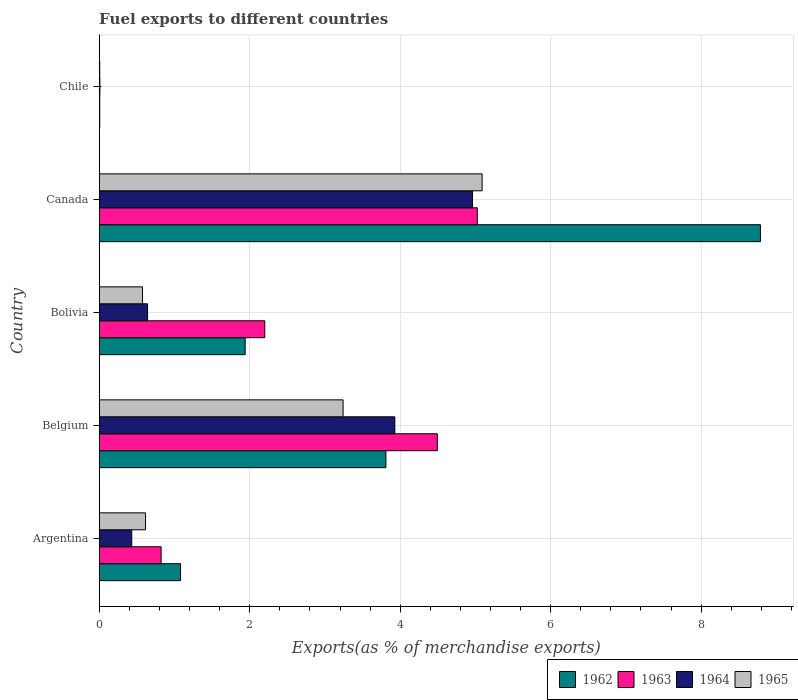Are the number of bars per tick equal to the number of legend labels?
Offer a very short reply. Yes. Are the number of bars on each tick of the Y-axis equal?
Provide a short and direct response. Yes. How many bars are there on the 2nd tick from the bottom?
Offer a very short reply. 4. What is the label of the 5th group of bars from the top?
Your answer should be compact. Argentina. What is the percentage of exports to different countries in 1962 in Belgium?
Offer a very short reply. 3.81. Across all countries, what is the maximum percentage of exports to different countries in 1963?
Ensure brevity in your answer.  5.02. Across all countries, what is the minimum percentage of exports to different countries in 1964?
Your answer should be compact. 0.01. In which country was the percentage of exports to different countries in 1965 minimum?
Give a very brief answer. Chile. What is the total percentage of exports to different countries in 1963 in the graph?
Your response must be concise. 12.55. What is the difference between the percentage of exports to different countries in 1962 in Belgium and that in Bolivia?
Keep it short and to the point. 1.87. What is the difference between the percentage of exports to different countries in 1964 in Chile and the percentage of exports to different countries in 1963 in Belgium?
Make the answer very short. -4.48. What is the average percentage of exports to different countries in 1965 per country?
Keep it short and to the point. 1.91. What is the difference between the percentage of exports to different countries in 1962 and percentage of exports to different countries in 1965 in Canada?
Your response must be concise. 3.7. What is the ratio of the percentage of exports to different countries in 1965 in Argentina to that in Canada?
Your response must be concise. 0.12. What is the difference between the highest and the second highest percentage of exports to different countries in 1965?
Ensure brevity in your answer.  1.85. What is the difference between the highest and the lowest percentage of exports to different countries in 1962?
Your answer should be very brief. 8.78. Is it the case that in every country, the sum of the percentage of exports to different countries in 1965 and percentage of exports to different countries in 1963 is greater than the sum of percentage of exports to different countries in 1964 and percentage of exports to different countries in 1962?
Your answer should be very brief. No. What does the 4th bar from the bottom in Belgium represents?
Keep it short and to the point. 1965. Is it the case that in every country, the sum of the percentage of exports to different countries in 1962 and percentage of exports to different countries in 1964 is greater than the percentage of exports to different countries in 1965?
Offer a terse response. Yes. How many bars are there?
Give a very brief answer. 20. How many countries are there in the graph?
Give a very brief answer. 5. What is the difference between two consecutive major ticks on the X-axis?
Offer a very short reply. 2. Does the graph contain any zero values?
Your response must be concise. No. Where does the legend appear in the graph?
Your answer should be compact. Bottom right. How many legend labels are there?
Provide a succinct answer. 4. How are the legend labels stacked?
Make the answer very short. Horizontal. What is the title of the graph?
Your response must be concise. Fuel exports to different countries. Does "2005" appear as one of the legend labels in the graph?
Your answer should be very brief. No. What is the label or title of the X-axis?
Your response must be concise. Exports(as % of merchandise exports). What is the Exports(as % of merchandise exports) of 1962 in Argentina?
Provide a short and direct response. 1.08. What is the Exports(as % of merchandise exports) in 1963 in Argentina?
Give a very brief answer. 0.82. What is the Exports(as % of merchandise exports) in 1964 in Argentina?
Make the answer very short. 0.43. What is the Exports(as % of merchandise exports) in 1965 in Argentina?
Give a very brief answer. 0.62. What is the Exports(as % of merchandise exports) of 1962 in Belgium?
Provide a short and direct response. 3.81. What is the Exports(as % of merchandise exports) in 1963 in Belgium?
Give a very brief answer. 4.49. What is the Exports(as % of merchandise exports) in 1964 in Belgium?
Your response must be concise. 3.93. What is the Exports(as % of merchandise exports) in 1965 in Belgium?
Ensure brevity in your answer.  3.24. What is the Exports(as % of merchandise exports) of 1962 in Bolivia?
Offer a terse response. 1.94. What is the Exports(as % of merchandise exports) of 1963 in Bolivia?
Make the answer very short. 2.2. What is the Exports(as % of merchandise exports) of 1964 in Bolivia?
Keep it short and to the point. 0.64. What is the Exports(as % of merchandise exports) of 1965 in Bolivia?
Offer a very short reply. 0.58. What is the Exports(as % of merchandise exports) of 1962 in Canada?
Your answer should be compact. 8.79. What is the Exports(as % of merchandise exports) in 1963 in Canada?
Your answer should be very brief. 5.02. What is the Exports(as % of merchandise exports) in 1964 in Canada?
Keep it short and to the point. 4.96. What is the Exports(as % of merchandise exports) in 1965 in Canada?
Provide a short and direct response. 5.09. What is the Exports(as % of merchandise exports) in 1962 in Chile?
Make the answer very short. 0.01. What is the Exports(as % of merchandise exports) in 1963 in Chile?
Offer a terse response. 0.01. What is the Exports(as % of merchandise exports) in 1964 in Chile?
Ensure brevity in your answer.  0.01. What is the Exports(as % of merchandise exports) in 1965 in Chile?
Give a very brief answer. 0.01. Across all countries, what is the maximum Exports(as % of merchandise exports) of 1962?
Ensure brevity in your answer.  8.79. Across all countries, what is the maximum Exports(as % of merchandise exports) of 1963?
Keep it short and to the point. 5.02. Across all countries, what is the maximum Exports(as % of merchandise exports) of 1964?
Your answer should be compact. 4.96. Across all countries, what is the maximum Exports(as % of merchandise exports) in 1965?
Provide a succinct answer. 5.09. Across all countries, what is the minimum Exports(as % of merchandise exports) of 1962?
Your response must be concise. 0.01. Across all countries, what is the minimum Exports(as % of merchandise exports) of 1963?
Make the answer very short. 0.01. Across all countries, what is the minimum Exports(as % of merchandise exports) of 1964?
Provide a short and direct response. 0.01. Across all countries, what is the minimum Exports(as % of merchandise exports) in 1965?
Make the answer very short. 0.01. What is the total Exports(as % of merchandise exports) of 1962 in the graph?
Your answer should be compact. 15.63. What is the total Exports(as % of merchandise exports) of 1963 in the graph?
Provide a succinct answer. 12.55. What is the total Exports(as % of merchandise exports) of 1964 in the graph?
Your answer should be very brief. 9.97. What is the total Exports(as % of merchandise exports) in 1965 in the graph?
Offer a very short reply. 9.53. What is the difference between the Exports(as % of merchandise exports) of 1962 in Argentina and that in Belgium?
Keep it short and to the point. -2.73. What is the difference between the Exports(as % of merchandise exports) in 1963 in Argentina and that in Belgium?
Ensure brevity in your answer.  -3.67. What is the difference between the Exports(as % of merchandise exports) in 1964 in Argentina and that in Belgium?
Make the answer very short. -3.5. What is the difference between the Exports(as % of merchandise exports) in 1965 in Argentina and that in Belgium?
Keep it short and to the point. -2.63. What is the difference between the Exports(as % of merchandise exports) of 1962 in Argentina and that in Bolivia?
Keep it short and to the point. -0.86. What is the difference between the Exports(as % of merchandise exports) of 1963 in Argentina and that in Bolivia?
Keep it short and to the point. -1.38. What is the difference between the Exports(as % of merchandise exports) in 1964 in Argentina and that in Bolivia?
Offer a very short reply. -0.21. What is the difference between the Exports(as % of merchandise exports) in 1965 in Argentina and that in Bolivia?
Your answer should be compact. 0.04. What is the difference between the Exports(as % of merchandise exports) of 1962 in Argentina and that in Canada?
Offer a terse response. -7.71. What is the difference between the Exports(as % of merchandise exports) of 1963 in Argentina and that in Canada?
Provide a short and direct response. -4.2. What is the difference between the Exports(as % of merchandise exports) of 1964 in Argentina and that in Canada?
Provide a succinct answer. -4.53. What is the difference between the Exports(as % of merchandise exports) in 1965 in Argentina and that in Canada?
Your answer should be compact. -4.47. What is the difference between the Exports(as % of merchandise exports) in 1962 in Argentina and that in Chile?
Keep it short and to the point. 1.07. What is the difference between the Exports(as % of merchandise exports) of 1963 in Argentina and that in Chile?
Ensure brevity in your answer.  0.82. What is the difference between the Exports(as % of merchandise exports) in 1964 in Argentina and that in Chile?
Provide a succinct answer. 0.42. What is the difference between the Exports(as % of merchandise exports) in 1965 in Argentina and that in Chile?
Ensure brevity in your answer.  0.61. What is the difference between the Exports(as % of merchandise exports) in 1962 in Belgium and that in Bolivia?
Offer a terse response. 1.87. What is the difference between the Exports(as % of merchandise exports) in 1963 in Belgium and that in Bolivia?
Your answer should be very brief. 2.29. What is the difference between the Exports(as % of merchandise exports) in 1964 in Belgium and that in Bolivia?
Keep it short and to the point. 3.29. What is the difference between the Exports(as % of merchandise exports) in 1965 in Belgium and that in Bolivia?
Keep it short and to the point. 2.67. What is the difference between the Exports(as % of merchandise exports) in 1962 in Belgium and that in Canada?
Your answer should be very brief. -4.98. What is the difference between the Exports(as % of merchandise exports) of 1963 in Belgium and that in Canada?
Offer a very short reply. -0.53. What is the difference between the Exports(as % of merchandise exports) of 1964 in Belgium and that in Canada?
Your response must be concise. -1.03. What is the difference between the Exports(as % of merchandise exports) in 1965 in Belgium and that in Canada?
Your answer should be very brief. -1.85. What is the difference between the Exports(as % of merchandise exports) in 1962 in Belgium and that in Chile?
Offer a very short reply. 3.8. What is the difference between the Exports(as % of merchandise exports) in 1963 in Belgium and that in Chile?
Keep it short and to the point. 4.49. What is the difference between the Exports(as % of merchandise exports) of 1964 in Belgium and that in Chile?
Give a very brief answer. 3.92. What is the difference between the Exports(as % of merchandise exports) in 1965 in Belgium and that in Chile?
Offer a terse response. 3.23. What is the difference between the Exports(as % of merchandise exports) of 1962 in Bolivia and that in Canada?
Your answer should be very brief. -6.85. What is the difference between the Exports(as % of merchandise exports) of 1963 in Bolivia and that in Canada?
Provide a short and direct response. -2.82. What is the difference between the Exports(as % of merchandise exports) in 1964 in Bolivia and that in Canada?
Make the answer very short. -4.32. What is the difference between the Exports(as % of merchandise exports) in 1965 in Bolivia and that in Canada?
Offer a terse response. -4.51. What is the difference between the Exports(as % of merchandise exports) in 1962 in Bolivia and that in Chile?
Give a very brief answer. 1.93. What is the difference between the Exports(as % of merchandise exports) of 1963 in Bolivia and that in Chile?
Offer a very short reply. 2.19. What is the difference between the Exports(as % of merchandise exports) of 1964 in Bolivia and that in Chile?
Your response must be concise. 0.63. What is the difference between the Exports(as % of merchandise exports) of 1965 in Bolivia and that in Chile?
Ensure brevity in your answer.  0.57. What is the difference between the Exports(as % of merchandise exports) in 1962 in Canada and that in Chile?
Your answer should be compact. 8.78. What is the difference between the Exports(as % of merchandise exports) of 1963 in Canada and that in Chile?
Keep it short and to the point. 5.02. What is the difference between the Exports(as % of merchandise exports) of 1964 in Canada and that in Chile?
Provide a short and direct response. 4.95. What is the difference between the Exports(as % of merchandise exports) in 1965 in Canada and that in Chile?
Ensure brevity in your answer.  5.08. What is the difference between the Exports(as % of merchandise exports) of 1962 in Argentina and the Exports(as % of merchandise exports) of 1963 in Belgium?
Offer a terse response. -3.41. What is the difference between the Exports(as % of merchandise exports) of 1962 in Argentina and the Exports(as % of merchandise exports) of 1964 in Belgium?
Keep it short and to the point. -2.85. What is the difference between the Exports(as % of merchandise exports) of 1962 in Argentina and the Exports(as % of merchandise exports) of 1965 in Belgium?
Provide a short and direct response. -2.16. What is the difference between the Exports(as % of merchandise exports) in 1963 in Argentina and the Exports(as % of merchandise exports) in 1964 in Belgium?
Offer a very short reply. -3.11. What is the difference between the Exports(as % of merchandise exports) of 1963 in Argentina and the Exports(as % of merchandise exports) of 1965 in Belgium?
Provide a succinct answer. -2.42. What is the difference between the Exports(as % of merchandise exports) in 1964 in Argentina and the Exports(as % of merchandise exports) in 1965 in Belgium?
Make the answer very short. -2.81. What is the difference between the Exports(as % of merchandise exports) in 1962 in Argentina and the Exports(as % of merchandise exports) in 1963 in Bolivia?
Offer a terse response. -1.12. What is the difference between the Exports(as % of merchandise exports) of 1962 in Argentina and the Exports(as % of merchandise exports) of 1964 in Bolivia?
Offer a very short reply. 0.44. What is the difference between the Exports(as % of merchandise exports) in 1962 in Argentina and the Exports(as % of merchandise exports) in 1965 in Bolivia?
Your answer should be compact. 0.51. What is the difference between the Exports(as % of merchandise exports) in 1963 in Argentina and the Exports(as % of merchandise exports) in 1964 in Bolivia?
Give a very brief answer. 0.18. What is the difference between the Exports(as % of merchandise exports) of 1963 in Argentina and the Exports(as % of merchandise exports) of 1965 in Bolivia?
Your answer should be compact. 0.25. What is the difference between the Exports(as % of merchandise exports) of 1964 in Argentina and the Exports(as % of merchandise exports) of 1965 in Bolivia?
Your response must be concise. -0.14. What is the difference between the Exports(as % of merchandise exports) in 1962 in Argentina and the Exports(as % of merchandise exports) in 1963 in Canada?
Keep it short and to the point. -3.94. What is the difference between the Exports(as % of merchandise exports) in 1962 in Argentina and the Exports(as % of merchandise exports) in 1964 in Canada?
Keep it short and to the point. -3.88. What is the difference between the Exports(as % of merchandise exports) in 1962 in Argentina and the Exports(as % of merchandise exports) in 1965 in Canada?
Give a very brief answer. -4.01. What is the difference between the Exports(as % of merchandise exports) in 1963 in Argentina and the Exports(as % of merchandise exports) in 1964 in Canada?
Offer a terse response. -4.14. What is the difference between the Exports(as % of merchandise exports) of 1963 in Argentina and the Exports(as % of merchandise exports) of 1965 in Canada?
Keep it short and to the point. -4.27. What is the difference between the Exports(as % of merchandise exports) in 1964 in Argentina and the Exports(as % of merchandise exports) in 1965 in Canada?
Keep it short and to the point. -4.66. What is the difference between the Exports(as % of merchandise exports) of 1962 in Argentina and the Exports(as % of merchandise exports) of 1963 in Chile?
Offer a terse response. 1.07. What is the difference between the Exports(as % of merchandise exports) of 1962 in Argentina and the Exports(as % of merchandise exports) of 1964 in Chile?
Ensure brevity in your answer.  1.07. What is the difference between the Exports(as % of merchandise exports) in 1962 in Argentina and the Exports(as % of merchandise exports) in 1965 in Chile?
Provide a short and direct response. 1.07. What is the difference between the Exports(as % of merchandise exports) of 1963 in Argentina and the Exports(as % of merchandise exports) of 1964 in Chile?
Offer a very short reply. 0.81. What is the difference between the Exports(as % of merchandise exports) in 1963 in Argentina and the Exports(as % of merchandise exports) in 1965 in Chile?
Your answer should be compact. 0.82. What is the difference between the Exports(as % of merchandise exports) in 1964 in Argentina and the Exports(as % of merchandise exports) in 1965 in Chile?
Offer a very short reply. 0.43. What is the difference between the Exports(as % of merchandise exports) in 1962 in Belgium and the Exports(as % of merchandise exports) in 1963 in Bolivia?
Make the answer very short. 1.61. What is the difference between the Exports(as % of merchandise exports) in 1962 in Belgium and the Exports(as % of merchandise exports) in 1964 in Bolivia?
Give a very brief answer. 3.17. What is the difference between the Exports(as % of merchandise exports) in 1962 in Belgium and the Exports(as % of merchandise exports) in 1965 in Bolivia?
Your answer should be compact. 3.23. What is the difference between the Exports(as % of merchandise exports) of 1963 in Belgium and the Exports(as % of merchandise exports) of 1964 in Bolivia?
Your answer should be very brief. 3.85. What is the difference between the Exports(as % of merchandise exports) in 1963 in Belgium and the Exports(as % of merchandise exports) in 1965 in Bolivia?
Keep it short and to the point. 3.92. What is the difference between the Exports(as % of merchandise exports) in 1964 in Belgium and the Exports(as % of merchandise exports) in 1965 in Bolivia?
Make the answer very short. 3.35. What is the difference between the Exports(as % of merchandise exports) in 1962 in Belgium and the Exports(as % of merchandise exports) in 1963 in Canada?
Ensure brevity in your answer.  -1.21. What is the difference between the Exports(as % of merchandise exports) of 1962 in Belgium and the Exports(as % of merchandise exports) of 1964 in Canada?
Provide a succinct answer. -1.15. What is the difference between the Exports(as % of merchandise exports) in 1962 in Belgium and the Exports(as % of merchandise exports) in 1965 in Canada?
Offer a terse response. -1.28. What is the difference between the Exports(as % of merchandise exports) of 1963 in Belgium and the Exports(as % of merchandise exports) of 1964 in Canada?
Ensure brevity in your answer.  -0.47. What is the difference between the Exports(as % of merchandise exports) in 1963 in Belgium and the Exports(as % of merchandise exports) in 1965 in Canada?
Your answer should be very brief. -0.6. What is the difference between the Exports(as % of merchandise exports) of 1964 in Belgium and the Exports(as % of merchandise exports) of 1965 in Canada?
Give a very brief answer. -1.16. What is the difference between the Exports(as % of merchandise exports) of 1962 in Belgium and the Exports(as % of merchandise exports) of 1963 in Chile?
Your answer should be compact. 3.8. What is the difference between the Exports(as % of merchandise exports) in 1962 in Belgium and the Exports(as % of merchandise exports) in 1964 in Chile?
Your answer should be compact. 3.8. What is the difference between the Exports(as % of merchandise exports) in 1962 in Belgium and the Exports(as % of merchandise exports) in 1965 in Chile?
Provide a succinct answer. 3.8. What is the difference between the Exports(as % of merchandise exports) of 1963 in Belgium and the Exports(as % of merchandise exports) of 1964 in Chile?
Your response must be concise. 4.48. What is the difference between the Exports(as % of merchandise exports) of 1963 in Belgium and the Exports(as % of merchandise exports) of 1965 in Chile?
Make the answer very short. 4.49. What is the difference between the Exports(as % of merchandise exports) in 1964 in Belgium and the Exports(as % of merchandise exports) in 1965 in Chile?
Offer a terse response. 3.92. What is the difference between the Exports(as % of merchandise exports) in 1962 in Bolivia and the Exports(as % of merchandise exports) in 1963 in Canada?
Offer a very short reply. -3.08. What is the difference between the Exports(as % of merchandise exports) of 1962 in Bolivia and the Exports(as % of merchandise exports) of 1964 in Canada?
Your response must be concise. -3.02. What is the difference between the Exports(as % of merchandise exports) of 1962 in Bolivia and the Exports(as % of merchandise exports) of 1965 in Canada?
Your response must be concise. -3.15. What is the difference between the Exports(as % of merchandise exports) of 1963 in Bolivia and the Exports(as % of merchandise exports) of 1964 in Canada?
Your answer should be compact. -2.76. What is the difference between the Exports(as % of merchandise exports) in 1963 in Bolivia and the Exports(as % of merchandise exports) in 1965 in Canada?
Your answer should be compact. -2.89. What is the difference between the Exports(as % of merchandise exports) in 1964 in Bolivia and the Exports(as % of merchandise exports) in 1965 in Canada?
Your response must be concise. -4.45. What is the difference between the Exports(as % of merchandise exports) in 1962 in Bolivia and the Exports(as % of merchandise exports) in 1963 in Chile?
Offer a terse response. 1.93. What is the difference between the Exports(as % of merchandise exports) in 1962 in Bolivia and the Exports(as % of merchandise exports) in 1964 in Chile?
Provide a succinct answer. 1.93. What is the difference between the Exports(as % of merchandise exports) of 1962 in Bolivia and the Exports(as % of merchandise exports) of 1965 in Chile?
Offer a terse response. 1.93. What is the difference between the Exports(as % of merchandise exports) in 1963 in Bolivia and the Exports(as % of merchandise exports) in 1964 in Chile?
Your response must be concise. 2.19. What is the difference between the Exports(as % of merchandise exports) of 1963 in Bolivia and the Exports(as % of merchandise exports) of 1965 in Chile?
Make the answer very short. 2.19. What is the difference between the Exports(as % of merchandise exports) of 1964 in Bolivia and the Exports(as % of merchandise exports) of 1965 in Chile?
Your response must be concise. 0.64. What is the difference between the Exports(as % of merchandise exports) in 1962 in Canada and the Exports(as % of merchandise exports) in 1963 in Chile?
Provide a succinct answer. 8.78. What is the difference between the Exports(as % of merchandise exports) in 1962 in Canada and the Exports(as % of merchandise exports) in 1964 in Chile?
Give a very brief answer. 8.78. What is the difference between the Exports(as % of merchandise exports) of 1962 in Canada and the Exports(as % of merchandise exports) of 1965 in Chile?
Your response must be concise. 8.78. What is the difference between the Exports(as % of merchandise exports) in 1963 in Canada and the Exports(as % of merchandise exports) in 1964 in Chile?
Your response must be concise. 5.02. What is the difference between the Exports(as % of merchandise exports) in 1963 in Canada and the Exports(as % of merchandise exports) in 1965 in Chile?
Your response must be concise. 5.02. What is the difference between the Exports(as % of merchandise exports) in 1964 in Canada and the Exports(as % of merchandise exports) in 1965 in Chile?
Provide a short and direct response. 4.95. What is the average Exports(as % of merchandise exports) in 1962 per country?
Your answer should be very brief. 3.13. What is the average Exports(as % of merchandise exports) in 1963 per country?
Your answer should be compact. 2.51. What is the average Exports(as % of merchandise exports) of 1964 per country?
Make the answer very short. 1.99. What is the average Exports(as % of merchandise exports) of 1965 per country?
Provide a succinct answer. 1.91. What is the difference between the Exports(as % of merchandise exports) of 1962 and Exports(as % of merchandise exports) of 1963 in Argentina?
Offer a very short reply. 0.26. What is the difference between the Exports(as % of merchandise exports) of 1962 and Exports(as % of merchandise exports) of 1964 in Argentina?
Your answer should be compact. 0.65. What is the difference between the Exports(as % of merchandise exports) of 1962 and Exports(as % of merchandise exports) of 1965 in Argentina?
Provide a succinct answer. 0.47. What is the difference between the Exports(as % of merchandise exports) of 1963 and Exports(as % of merchandise exports) of 1964 in Argentina?
Your response must be concise. 0.39. What is the difference between the Exports(as % of merchandise exports) of 1963 and Exports(as % of merchandise exports) of 1965 in Argentina?
Your response must be concise. 0.21. What is the difference between the Exports(as % of merchandise exports) of 1964 and Exports(as % of merchandise exports) of 1965 in Argentina?
Keep it short and to the point. -0.18. What is the difference between the Exports(as % of merchandise exports) of 1962 and Exports(as % of merchandise exports) of 1963 in Belgium?
Your answer should be compact. -0.68. What is the difference between the Exports(as % of merchandise exports) of 1962 and Exports(as % of merchandise exports) of 1964 in Belgium?
Provide a short and direct response. -0.12. What is the difference between the Exports(as % of merchandise exports) of 1962 and Exports(as % of merchandise exports) of 1965 in Belgium?
Ensure brevity in your answer.  0.57. What is the difference between the Exports(as % of merchandise exports) of 1963 and Exports(as % of merchandise exports) of 1964 in Belgium?
Your answer should be very brief. 0.56. What is the difference between the Exports(as % of merchandise exports) of 1963 and Exports(as % of merchandise exports) of 1965 in Belgium?
Make the answer very short. 1.25. What is the difference between the Exports(as % of merchandise exports) of 1964 and Exports(as % of merchandise exports) of 1965 in Belgium?
Offer a terse response. 0.69. What is the difference between the Exports(as % of merchandise exports) of 1962 and Exports(as % of merchandise exports) of 1963 in Bolivia?
Ensure brevity in your answer.  -0.26. What is the difference between the Exports(as % of merchandise exports) of 1962 and Exports(as % of merchandise exports) of 1964 in Bolivia?
Offer a very short reply. 1.3. What is the difference between the Exports(as % of merchandise exports) in 1962 and Exports(as % of merchandise exports) in 1965 in Bolivia?
Keep it short and to the point. 1.36. What is the difference between the Exports(as % of merchandise exports) in 1963 and Exports(as % of merchandise exports) in 1964 in Bolivia?
Keep it short and to the point. 1.56. What is the difference between the Exports(as % of merchandise exports) in 1963 and Exports(as % of merchandise exports) in 1965 in Bolivia?
Offer a terse response. 1.62. What is the difference between the Exports(as % of merchandise exports) of 1964 and Exports(as % of merchandise exports) of 1965 in Bolivia?
Your response must be concise. 0.07. What is the difference between the Exports(as % of merchandise exports) of 1962 and Exports(as % of merchandise exports) of 1963 in Canada?
Offer a terse response. 3.76. What is the difference between the Exports(as % of merchandise exports) of 1962 and Exports(as % of merchandise exports) of 1964 in Canada?
Give a very brief answer. 3.83. What is the difference between the Exports(as % of merchandise exports) in 1962 and Exports(as % of merchandise exports) in 1965 in Canada?
Offer a terse response. 3.7. What is the difference between the Exports(as % of merchandise exports) of 1963 and Exports(as % of merchandise exports) of 1964 in Canada?
Ensure brevity in your answer.  0.06. What is the difference between the Exports(as % of merchandise exports) in 1963 and Exports(as % of merchandise exports) in 1965 in Canada?
Make the answer very short. -0.06. What is the difference between the Exports(as % of merchandise exports) of 1964 and Exports(as % of merchandise exports) of 1965 in Canada?
Keep it short and to the point. -0.13. What is the difference between the Exports(as % of merchandise exports) in 1962 and Exports(as % of merchandise exports) in 1963 in Chile?
Your answer should be very brief. -0. What is the difference between the Exports(as % of merchandise exports) of 1962 and Exports(as % of merchandise exports) of 1964 in Chile?
Keep it short and to the point. -0. What is the difference between the Exports(as % of merchandise exports) in 1962 and Exports(as % of merchandise exports) in 1965 in Chile?
Ensure brevity in your answer.  0. What is the difference between the Exports(as % of merchandise exports) of 1963 and Exports(as % of merchandise exports) of 1964 in Chile?
Provide a short and direct response. -0. What is the difference between the Exports(as % of merchandise exports) of 1963 and Exports(as % of merchandise exports) of 1965 in Chile?
Provide a succinct answer. 0. What is the difference between the Exports(as % of merchandise exports) of 1964 and Exports(as % of merchandise exports) of 1965 in Chile?
Make the answer very short. 0. What is the ratio of the Exports(as % of merchandise exports) of 1962 in Argentina to that in Belgium?
Make the answer very short. 0.28. What is the ratio of the Exports(as % of merchandise exports) of 1963 in Argentina to that in Belgium?
Your response must be concise. 0.18. What is the ratio of the Exports(as % of merchandise exports) of 1964 in Argentina to that in Belgium?
Provide a succinct answer. 0.11. What is the ratio of the Exports(as % of merchandise exports) of 1965 in Argentina to that in Belgium?
Your response must be concise. 0.19. What is the ratio of the Exports(as % of merchandise exports) in 1962 in Argentina to that in Bolivia?
Your answer should be compact. 0.56. What is the ratio of the Exports(as % of merchandise exports) in 1963 in Argentina to that in Bolivia?
Ensure brevity in your answer.  0.37. What is the ratio of the Exports(as % of merchandise exports) of 1964 in Argentina to that in Bolivia?
Ensure brevity in your answer.  0.67. What is the ratio of the Exports(as % of merchandise exports) of 1965 in Argentina to that in Bolivia?
Keep it short and to the point. 1.07. What is the ratio of the Exports(as % of merchandise exports) of 1962 in Argentina to that in Canada?
Provide a succinct answer. 0.12. What is the ratio of the Exports(as % of merchandise exports) of 1963 in Argentina to that in Canada?
Give a very brief answer. 0.16. What is the ratio of the Exports(as % of merchandise exports) of 1964 in Argentina to that in Canada?
Offer a terse response. 0.09. What is the ratio of the Exports(as % of merchandise exports) of 1965 in Argentina to that in Canada?
Ensure brevity in your answer.  0.12. What is the ratio of the Exports(as % of merchandise exports) of 1962 in Argentina to that in Chile?
Your response must be concise. 154.28. What is the ratio of the Exports(as % of merchandise exports) of 1963 in Argentina to that in Chile?
Offer a terse response. 116.11. What is the ratio of the Exports(as % of merchandise exports) in 1964 in Argentina to that in Chile?
Offer a very short reply. 48.39. What is the ratio of the Exports(as % of merchandise exports) of 1965 in Argentina to that in Chile?
Offer a terse response. 91.07. What is the ratio of the Exports(as % of merchandise exports) of 1962 in Belgium to that in Bolivia?
Offer a very short reply. 1.96. What is the ratio of the Exports(as % of merchandise exports) of 1963 in Belgium to that in Bolivia?
Provide a succinct answer. 2.04. What is the ratio of the Exports(as % of merchandise exports) in 1964 in Belgium to that in Bolivia?
Provide a short and direct response. 6.12. What is the ratio of the Exports(as % of merchandise exports) of 1965 in Belgium to that in Bolivia?
Ensure brevity in your answer.  5.63. What is the ratio of the Exports(as % of merchandise exports) of 1962 in Belgium to that in Canada?
Your answer should be compact. 0.43. What is the ratio of the Exports(as % of merchandise exports) of 1963 in Belgium to that in Canada?
Give a very brief answer. 0.89. What is the ratio of the Exports(as % of merchandise exports) in 1964 in Belgium to that in Canada?
Offer a very short reply. 0.79. What is the ratio of the Exports(as % of merchandise exports) in 1965 in Belgium to that in Canada?
Ensure brevity in your answer.  0.64. What is the ratio of the Exports(as % of merchandise exports) of 1962 in Belgium to that in Chile?
Offer a terse response. 543.89. What is the ratio of the Exports(as % of merchandise exports) of 1963 in Belgium to that in Chile?
Keep it short and to the point. 634.23. What is the ratio of the Exports(as % of merchandise exports) in 1964 in Belgium to that in Chile?
Keep it short and to the point. 439.88. What is the ratio of the Exports(as % of merchandise exports) of 1965 in Belgium to that in Chile?
Your answer should be very brief. 479.5. What is the ratio of the Exports(as % of merchandise exports) in 1962 in Bolivia to that in Canada?
Your answer should be compact. 0.22. What is the ratio of the Exports(as % of merchandise exports) of 1963 in Bolivia to that in Canada?
Offer a very short reply. 0.44. What is the ratio of the Exports(as % of merchandise exports) of 1964 in Bolivia to that in Canada?
Give a very brief answer. 0.13. What is the ratio of the Exports(as % of merchandise exports) of 1965 in Bolivia to that in Canada?
Your answer should be very brief. 0.11. What is the ratio of the Exports(as % of merchandise exports) of 1962 in Bolivia to that in Chile?
Ensure brevity in your answer.  276.87. What is the ratio of the Exports(as % of merchandise exports) of 1963 in Bolivia to that in Chile?
Provide a succinct answer. 310.59. What is the ratio of the Exports(as % of merchandise exports) in 1964 in Bolivia to that in Chile?
Keep it short and to the point. 71.92. What is the ratio of the Exports(as % of merchandise exports) of 1965 in Bolivia to that in Chile?
Your response must be concise. 85.13. What is the ratio of the Exports(as % of merchandise exports) of 1962 in Canada to that in Chile?
Keep it short and to the point. 1254.38. What is the ratio of the Exports(as % of merchandise exports) in 1963 in Canada to that in Chile?
Give a very brief answer. 709.22. What is the ratio of the Exports(as % of merchandise exports) in 1964 in Canada to that in Chile?
Provide a succinct answer. 555.45. What is the ratio of the Exports(as % of merchandise exports) of 1965 in Canada to that in Chile?
Your response must be concise. 752.83. What is the difference between the highest and the second highest Exports(as % of merchandise exports) in 1962?
Give a very brief answer. 4.98. What is the difference between the highest and the second highest Exports(as % of merchandise exports) of 1963?
Make the answer very short. 0.53. What is the difference between the highest and the second highest Exports(as % of merchandise exports) in 1964?
Offer a very short reply. 1.03. What is the difference between the highest and the second highest Exports(as % of merchandise exports) of 1965?
Give a very brief answer. 1.85. What is the difference between the highest and the lowest Exports(as % of merchandise exports) in 1962?
Make the answer very short. 8.78. What is the difference between the highest and the lowest Exports(as % of merchandise exports) in 1963?
Make the answer very short. 5.02. What is the difference between the highest and the lowest Exports(as % of merchandise exports) in 1964?
Give a very brief answer. 4.95. What is the difference between the highest and the lowest Exports(as % of merchandise exports) of 1965?
Give a very brief answer. 5.08. 